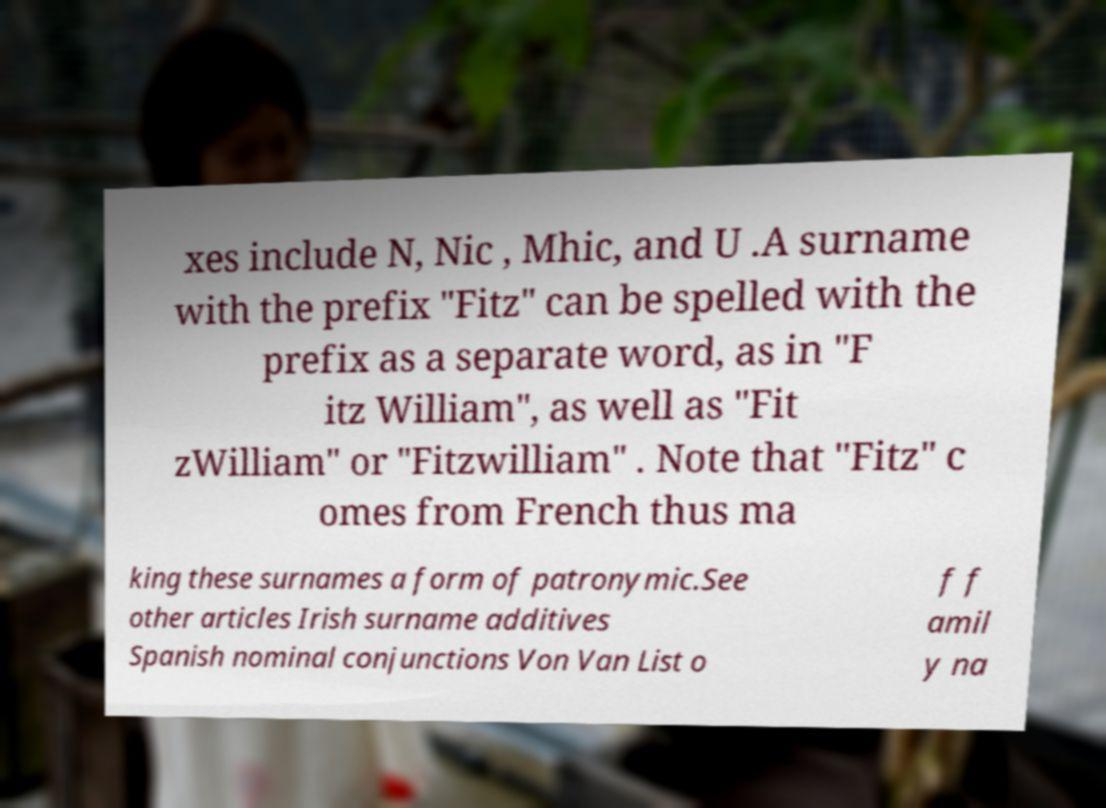Could you extract and type out the text from this image? xes include N, Nic , Mhic, and U .A surname with the prefix "Fitz" can be spelled with the prefix as a separate word, as in "F itz William", as well as "Fit zWilliam" or "Fitzwilliam" . Note that "Fitz" c omes from French thus ma king these surnames a form of patronymic.See other articles Irish surname additives Spanish nominal conjunctions Von Van List o f f amil y na 